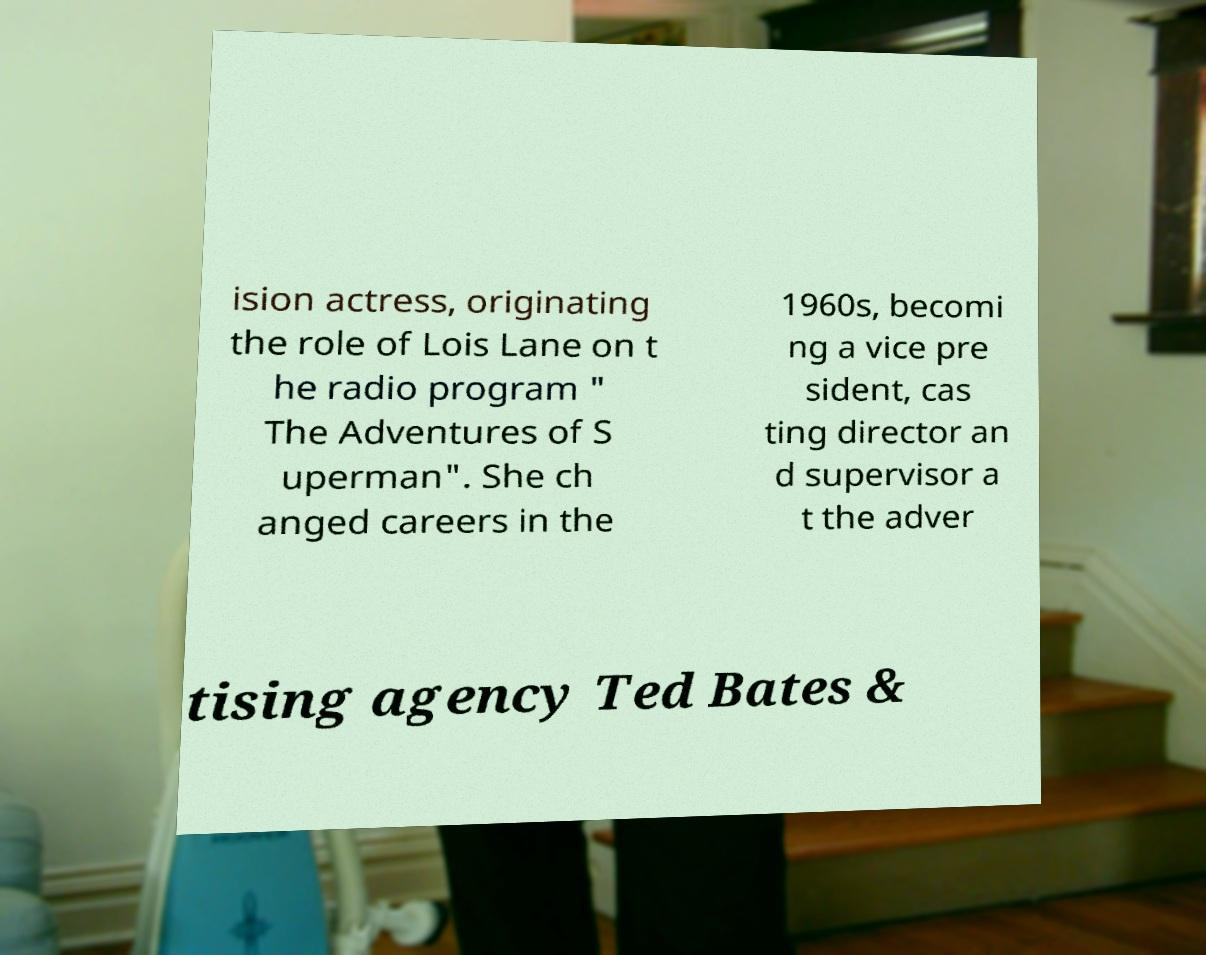Could you extract and type out the text from this image? ision actress, originating the role of Lois Lane on t he radio program " The Adventures of S uperman". She ch anged careers in the 1960s, becomi ng a vice pre sident, cas ting director an d supervisor a t the adver tising agency Ted Bates & 